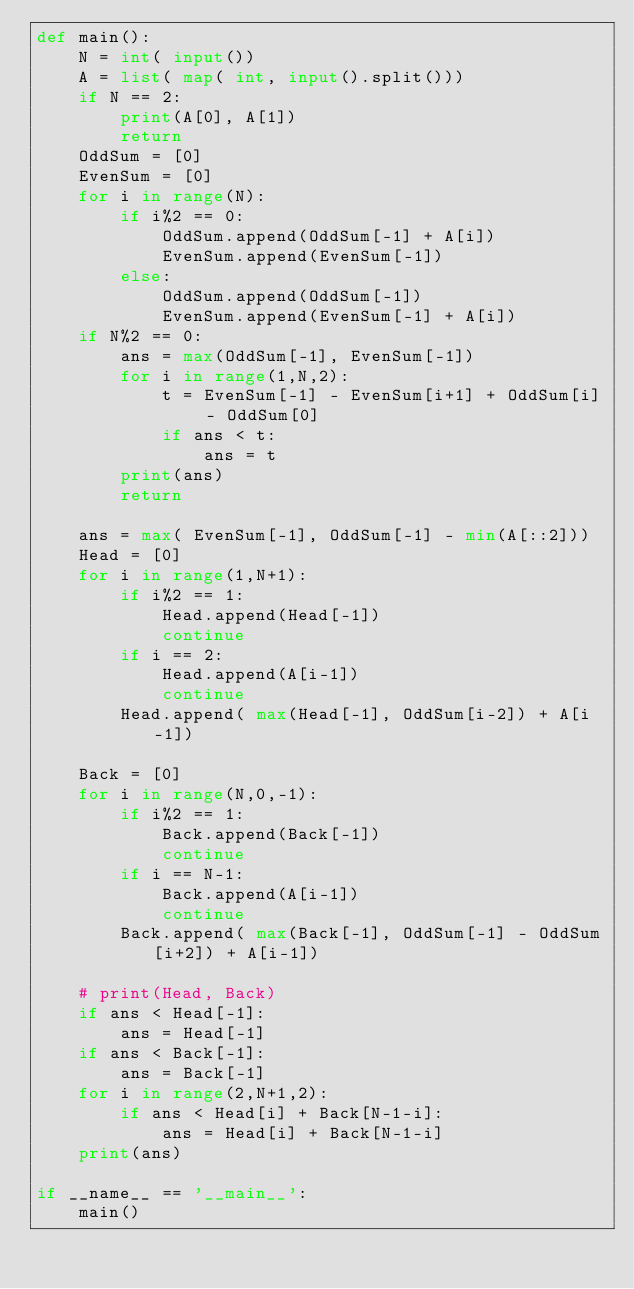Convert code to text. <code><loc_0><loc_0><loc_500><loc_500><_Python_>def main():
    N = int( input())
    A = list( map( int, input().split()))
    if N == 2:
        print(A[0], A[1])
        return
    OddSum = [0]
    EvenSum = [0]
    for i in range(N):
        if i%2 == 0:
            OddSum.append(OddSum[-1] + A[i])
            EvenSum.append(EvenSum[-1])
        else:
            OddSum.append(OddSum[-1])
            EvenSum.append(EvenSum[-1] + A[i])
    if N%2 == 0:
        ans = max(OddSum[-1], EvenSum[-1])
        for i in range(1,N,2):
            t = EvenSum[-1] - EvenSum[i+1] + OddSum[i] - OddSum[0]
            if ans < t:
                ans = t
        print(ans)
        return

    ans = max( EvenSum[-1], OddSum[-1] - min(A[::2]))
    Head = [0]
    for i in range(1,N+1):
        if i%2 == 1:
            Head.append(Head[-1])
            continue
        if i == 2:
            Head.append(A[i-1])
            continue
        Head.append( max(Head[-1], OddSum[i-2]) + A[i-1])

    Back = [0]
    for i in range(N,0,-1):
        if i%2 == 1:
            Back.append(Back[-1])
            continue
        if i == N-1:
            Back.append(A[i-1])
            continue
        Back.append( max(Back[-1], OddSum[-1] - OddSum[i+2]) + A[i-1])

    # print(Head, Back)
    if ans < Head[-1]:
        ans = Head[-1]
    if ans < Back[-1]:
        ans = Back[-1]
    for i in range(2,N+1,2):
        if ans < Head[i] + Back[N-1-i]:
            ans = Head[i] + Back[N-1-i]
    print(ans)
    
if __name__ == '__main__':
    main()
</code> 